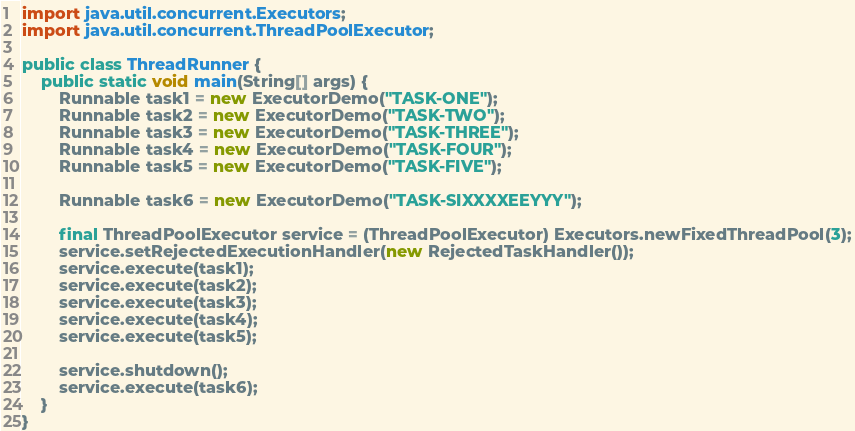Convert code to text. <code><loc_0><loc_0><loc_500><loc_500><_Java_>import java.util.concurrent.Executors;
import java.util.concurrent.ThreadPoolExecutor;

public class ThreadRunner {
    public static void main(String[] args) {
        Runnable task1 = new ExecutorDemo("TASK-ONE");
        Runnable task2 = new ExecutorDemo("TASK-TWO");
        Runnable task3 = new ExecutorDemo("TASK-THREE");
        Runnable task4 = new ExecutorDemo("TASK-FOUR");
        Runnable task5 = new ExecutorDemo("TASK-FIVE");

        Runnable task6 = new ExecutorDemo("TASK-SIXXXXEEYYY");

        final ThreadPoolExecutor service = (ThreadPoolExecutor) Executors.newFixedThreadPool(3);
        service.setRejectedExecutionHandler(new RejectedTaskHandler());
        service.execute(task1);
        service.execute(task2);
        service.execute(task3);
        service.execute(task4);
        service.execute(task5);

        service.shutdown();
        service.execute(task6);
    }
}
</code> 